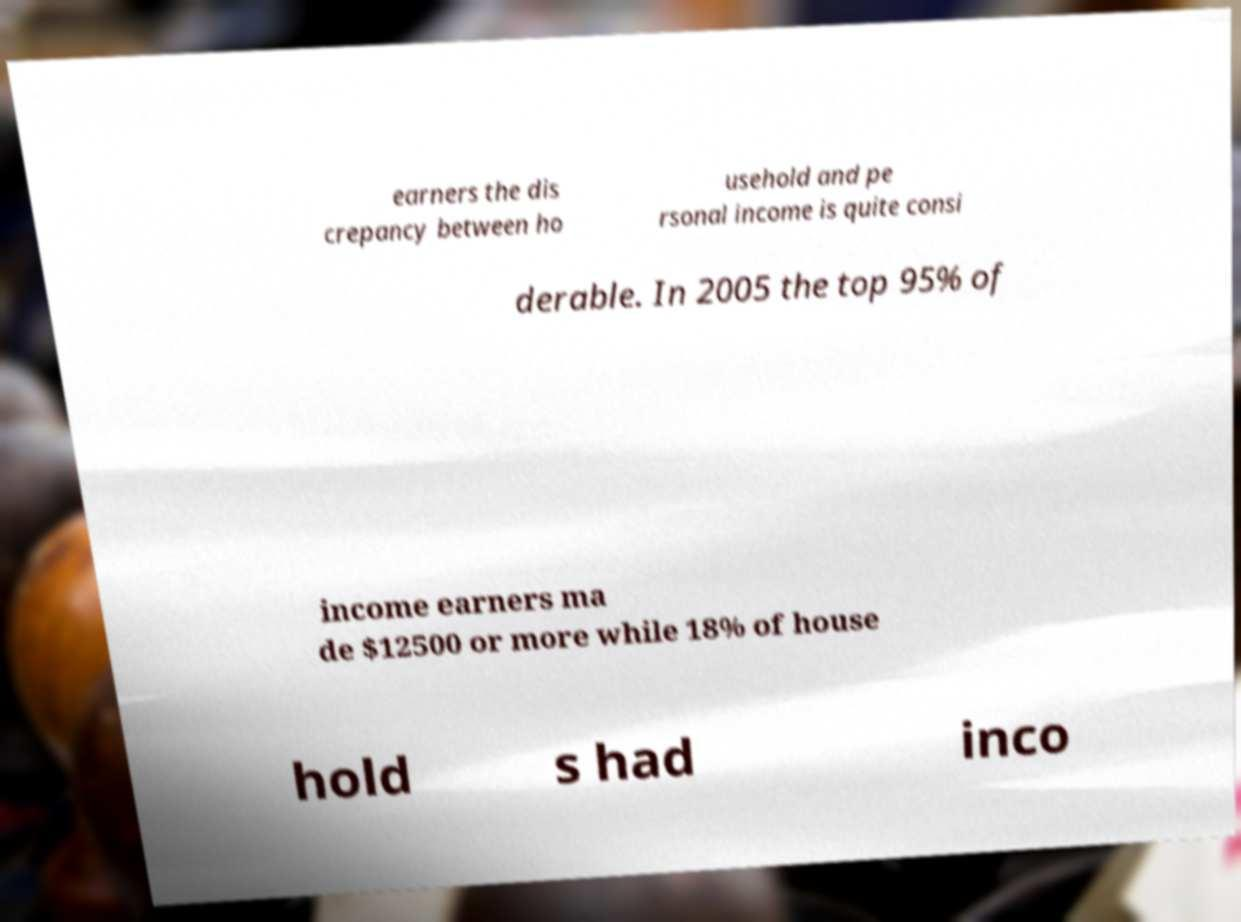I need the written content from this picture converted into text. Can you do that? earners the dis crepancy between ho usehold and pe rsonal income is quite consi derable. In 2005 the top 95% of income earners ma de $12500 or more while 18% of house hold s had inco 